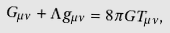<formula> <loc_0><loc_0><loc_500><loc_500>G _ { \mu \nu } + \Lambda g _ { \mu \nu } = 8 \pi G T _ { \mu \nu } ,</formula> 